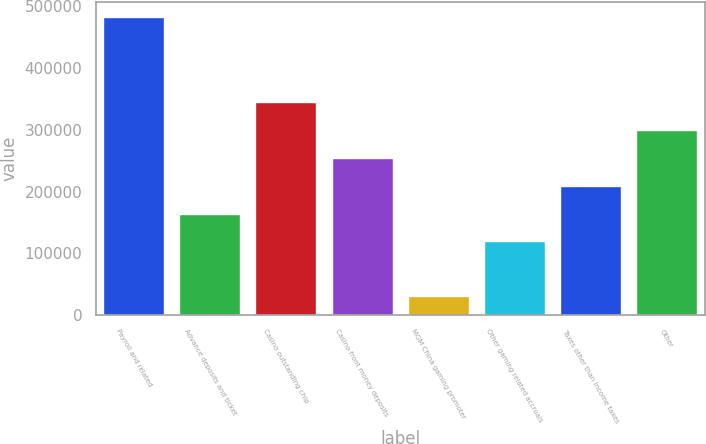<chart> <loc_0><loc_0><loc_500><loc_500><bar_chart><fcel>Payroll and related<fcel>Advance deposits and ticket<fcel>Casino outstanding chip<fcel>Casino front money deposits<fcel>MGM China gaming promoter<fcel>Other gaming related accruals<fcel>Taxes other than income taxes<fcel>Other<nl><fcel>483194<fcel>164621<fcel>345320<fcel>254971<fcel>31445<fcel>119446<fcel>209796<fcel>300146<nl></chart> 